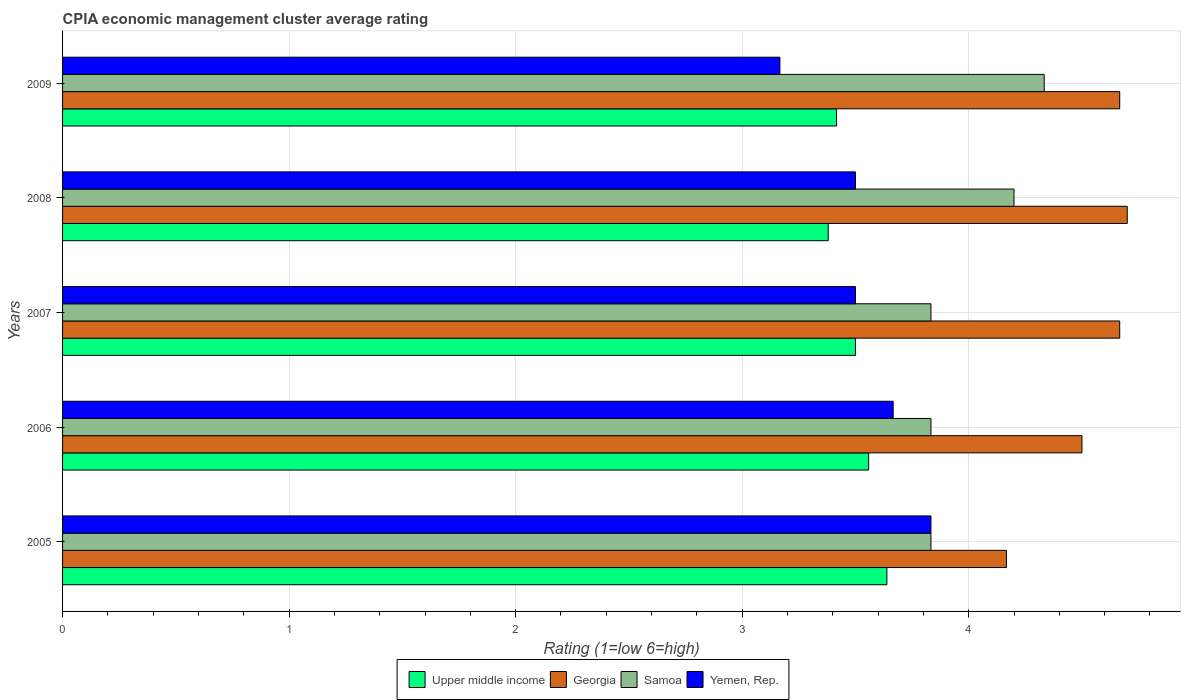How many different coloured bars are there?
Give a very brief answer. 4. How many groups of bars are there?
Your answer should be compact. 5. Are the number of bars on each tick of the Y-axis equal?
Your answer should be compact. Yes. How many bars are there on the 1st tick from the top?
Offer a terse response. 4. How many bars are there on the 1st tick from the bottom?
Ensure brevity in your answer.  4. What is the label of the 4th group of bars from the top?
Keep it short and to the point. 2006. What is the CPIA rating in Upper middle income in 2006?
Provide a short and direct response. 3.56. Across all years, what is the minimum CPIA rating in Yemen, Rep.?
Give a very brief answer. 3.17. In which year was the CPIA rating in Samoa maximum?
Ensure brevity in your answer.  2009. What is the total CPIA rating in Upper middle income in the graph?
Make the answer very short. 17.49. What is the difference between the CPIA rating in Georgia in 2006 and that in 2007?
Make the answer very short. -0.17. What is the difference between the CPIA rating in Upper middle income in 2009 and the CPIA rating in Yemen, Rep. in 2007?
Your answer should be very brief. -0.08. What is the average CPIA rating in Samoa per year?
Keep it short and to the point. 4.01. What is the ratio of the CPIA rating in Yemen, Rep. in 2007 to that in 2009?
Make the answer very short. 1.11. What is the difference between the highest and the second highest CPIA rating in Yemen, Rep.?
Provide a succinct answer. 0.17. What is the difference between the highest and the lowest CPIA rating in Georgia?
Ensure brevity in your answer.  0.53. In how many years, is the CPIA rating in Upper middle income greater than the average CPIA rating in Upper middle income taken over all years?
Your answer should be compact. 3. Is the sum of the CPIA rating in Georgia in 2007 and 2008 greater than the maximum CPIA rating in Upper middle income across all years?
Keep it short and to the point. Yes. Is it the case that in every year, the sum of the CPIA rating in Samoa and CPIA rating in Upper middle income is greater than the sum of CPIA rating in Georgia and CPIA rating in Yemen, Rep.?
Provide a short and direct response. No. What does the 1st bar from the top in 2007 represents?
Ensure brevity in your answer.  Yemen, Rep. What does the 1st bar from the bottom in 2008 represents?
Provide a short and direct response. Upper middle income. Is it the case that in every year, the sum of the CPIA rating in Yemen, Rep. and CPIA rating in Upper middle income is greater than the CPIA rating in Georgia?
Ensure brevity in your answer.  Yes. Are all the bars in the graph horizontal?
Make the answer very short. Yes. How many years are there in the graph?
Give a very brief answer. 5. Are the values on the major ticks of X-axis written in scientific E-notation?
Provide a short and direct response. No. Does the graph contain grids?
Keep it short and to the point. Yes. Where does the legend appear in the graph?
Your answer should be compact. Bottom center. How many legend labels are there?
Provide a succinct answer. 4. How are the legend labels stacked?
Your answer should be compact. Horizontal. What is the title of the graph?
Offer a very short reply. CPIA economic management cluster average rating. What is the Rating (1=low 6=high) in Upper middle income in 2005?
Provide a short and direct response. 3.64. What is the Rating (1=low 6=high) in Georgia in 2005?
Offer a very short reply. 4.17. What is the Rating (1=low 6=high) of Samoa in 2005?
Ensure brevity in your answer.  3.83. What is the Rating (1=low 6=high) in Yemen, Rep. in 2005?
Your answer should be compact. 3.83. What is the Rating (1=low 6=high) of Upper middle income in 2006?
Provide a short and direct response. 3.56. What is the Rating (1=low 6=high) in Georgia in 2006?
Offer a very short reply. 4.5. What is the Rating (1=low 6=high) in Samoa in 2006?
Give a very brief answer. 3.83. What is the Rating (1=low 6=high) in Yemen, Rep. in 2006?
Ensure brevity in your answer.  3.67. What is the Rating (1=low 6=high) in Georgia in 2007?
Offer a terse response. 4.67. What is the Rating (1=low 6=high) in Samoa in 2007?
Provide a short and direct response. 3.83. What is the Rating (1=low 6=high) of Upper middle income in 2008?
Provide a succinct answer. 3.38. What is the Rating (1=low 6=high) in Georgia in 2008?
Provide a short and direct response. 4.7. What is the Rating (1=low 6=high) of Samoa in 2008?
Your answer should be very brief. 4.2. What is the Rating (1=low 6=high) of Upper middle income in 2009?
Make the answer very short. 3.42. What is the Rating (1=low 6=high) of Georgia in 2009?
Make the answer very short. 4.67. What is the Rating (1=low 6=high) of Samoa in 2009?
Your answer should be very brief. 4.33. What is the Rating (1=low 6=high) of Yemen, Rep. in 2009?
Provide a short and direct response. 3.17. Across all years, what is the maximum Rating (1=low 6=high) in Upper middle income?
Provide a succinct answer. 3.64. Across all years, what is the maximum Rating (1=low 6=high) in Georgia?
Provide a short and direct response. 4.7. Across all years, what is the maximum Rating (1=low 6=high) in Samoa?
Make the answer very short. 4.33. Across all years, what is the maximum Rating (1=low 6=high) in Yemen, Rep.?
Your answer should be compact. 3.83. Across all years, what is the minimum Rating (1=low 6=high) of Upper middle income?
Provide a succinct answer. 3.38. Across all years, what is the minimum Rating (1=low 6=high) in Georgia?
Your response must be concise. 4.17. Across all years, what is the minimum Rating (1=low 6=high) in Samoa?
Make the answer very short. 3.83. Across all years, what is the minimum Rating (1=low 6=high) in Yemen, Rep.?
Provide a succinct answer. 3.17. What is the total Rating (1=low 6=high) of Upper middle income in the graph?
Your response must be concise. 17.49. What is the total Rating (1=low 6=high) in Georgia in the graph?
Your answer should be very brief. 22.7. What is the total Rating (1=low 6=high) of Samoa in the graph?
Keep it short and to the point. 20.03. What is the total Rating (1=low 6=high) of Yemen, Rep. in the graph?
Offer a very short reply. 17.67. What is the difference between the Rating (1=low 6=high) in Upper middle income in 2005 and that in 2006?
Keep it short and to the point. 0.08. What is the difference between the Rating (1=low 6=high) of Georgia in 2005 and that in 2006?
Provide a succinct answer. -0.33. What is the difference between the Rating (1=low 6=high) of Upper middle income in 2005 and that in 2007?
Your response must be concise. 0.14. What is the difference between the Rating (1=low 6=high) in Yemen, Rep. in 2005 and that in 2007?
Your response must be concise. 0.33. What is the difference between the Rating (1=low 6=high) of Upper middle income in 2005 and that in 2008?
Your answer should be very brief. 0.26. What is the difference between the Rating (1=low 6=high) in Georgia in 2005 and that in 2008?
Your answer should be very brief. -0.53. What is the difference between the Rating (1=low 6=high) of Samoa in 2005 and that in 2008?
Offer a terse response. -0.37. What is the difference between the Rating (1=low 6=high) of Upper middle income in 2005 and that in 2009?
Offer a very short reply. 0.22. What is the difference between the Rating (1=low 6=high) in Samoa in 2005 and that in 2009?
Provide a succinct answer. -0.5. What is the difference between the Rating (1=low 6=high) in Upper middle income in 2006 and that in 2007?
Give a very brief answer. 0.06. What is the difference between the Rating (1=low 6=high) in Yemen, Rep. in 2006 and that in 2007?
Offer a very short reply. 0.17. What is the difference between the Rating (1=low 6=high) of Upper middle income in 2006 and that in 2008?
Provide a succinct answer. 0.18. What is the difference between the Rating (1=low 6=high) in Samoa in 2006 and that in 2008?
Keep it short and to the point. -0.37. What is the difference between the Rating (1=low 6=high) in Upper middle income in 2006 and that in 2009?
Offer a very short reply. 0.14. What is the difference between the Rating (1=low 6=high) in Samoa in 2006 and that in 2009?
Offer a terse response. -0.5. What is the difference between the Rating (1=low 6=high) in Upper middle income in 2007 and that in 2008?
Offer a very short reply. 0.12. What is the difference between the Rating (1=low 6=high) in Georgia in 2007 and that in 2008?
Your answer should be very brief. -0.03. What is the difference between the Rating (1=low 6=high) in Samoa in 2007 and that in 2008?
Your answer should be compact. -0.37. What is the difference between the Rating (1=low 6=high) in Yemen, Rep. in 2007 and that in 2008?
Offer a very short reply. 0. What is the difference between the Rating (1=low 6=high) in Upper middle income in 2007 and that in 2009?
Offer a terse response. 0.08. What is the difference between the Rating (1=low 6=high) in Samoa in 2007 and that in 2009?
Provide a short and direct response. -0.5. What is the difference between the Rating (1=low 6=high) of Yemen, Rep. in 2007 and that in 2009?
Keep it short and to the point. 0.33. What is the difference between the Rating (1=low 6=high) in Upper middle income in 2008 and that in 2009?
Offer a terse response. -0.04. What is the difference between the Rating (1=low 6=high) in Samoa in 2008 and that in 2009?
Give a very brief answer. -0.13. What is the difference between the Rating (1=low 6=high) in Yemen, Rep. in 2008 and that in 2009?
Your answer should be compact. 0.33. What is the difference between the Rating (1=low 6=high) in Upper middle income in 2005 and the Rating (1=low 6=high) in Georgia in 2006?
Your answer should be compact. -0.86. What is the difference between the Rating (1=low 6=high) in Upper middle income in 2005 and the Rating (1=low 6=high) in Samoa in 2006?
Make the answer very short. -0.19. What is the difference between the Rating (1=low 6=high) of Upper middle income in 2005 and the Rating (1=low 6=high) of Yemen, Rep. in 2006?
Provide a short and direct response. -0.03. What is the difference between the Rating (1=low 6=high) of Georgia in 2005 and the Rating (1=low 6=high) of Samoa in 2006?
Give a very brief answer. 0.33. What is the difference between the Rating (1=low 6=high) in Upper middle income in 2005 and the Rating (1=low 6=high) in Georgia in 2007?
Your answer should be compact. -1.03. What is the difference between the Rating (1=low 6=high) in Upper middle income in 2005 and the Rating (1=low 6=high) in Samoa in 2007?
Provide a succinct answer. -0.19. What is the difference between the Rating (1=low 6=high) of Upper middle income in 2005 and the Rating (1=low 6=high) of Yemen, Rep. in 2007?
Give a very brief answer. 0.14. What is the difference between the Rating (1=low 6=high) in Georgia in 2005 and the Rating (1=low 6=high) in Samoa in 2007?
Give a very brief answer. 0.33. What is the difference between the Rating (1=low 6=high) of Samoa in 2005 and the Rating (1=low 6=high) of Yemen, Rep. in 2007?
Keep it short and to the point. 0.33. What is the difference between the Rating (1=low 6=high) in Upper middle income in 2005 and the Rating (1=low 6=high) in Georgia in 2008?
Your answer should be very brief. -1.06. What is the difference between the Rating (1=low 6=high) of Upper middle income in 2005 and the Rating (1=low 6=high) of Samoa in 2008?
Ensure brevity in your answer.  -0.56. What is the difference between the Rating (1=low 6=high) in Upper middle income in 2005 and the Rating (1=low 6=high) in Yemen, Rep. in 2008?
Provide a succinct answer. 0.14. What is the difference between the Rating (1=low 6=high) of Georgia in 2005 and the Rating (1=low 6=high) of Samoa in 2008?
Your answer should be compact. -0.03. What is the difference between the Rating (1=low 6=high) of Georgia in 2005 and the Rating (1=low 6=high) of Yemen, Rep. in 2008?
Keep it short and to the point. 0.67. What is the difference between the Rating (1=low 6=high) of Samoa in 2005 and the Rating (1=low 6=high) of Yemen, Rep. in 2008?
Keep it short and to the point. 0.33. What is the difference between the Rating (1=low 6=high) in Upper middle income in 2005 and the Rating (1=low 6=high) in Georgia in 2009?
Your answer should be compact. -1.03. What is the difference between the Rating (1=low 6=high) of Upper middle income in 2005 and the Rating (1=low 6=high) of Samoa in 2009?
Offer a very short reply. -0.69. What is the difference between the Rating (1=low 6=high) in Upper middle income in 2005 and the Rating (1=low 6=high) in Yemen, Rep. in 2009?
Offer a terse response. 0.47. What is the difference between the Rating (1=low 6=high) in Georgia in 2005 and the Rating (1=low 6=high) in Samoa in 2009?
Your answer should be very brief. -0.17. What is the difference between the Rating (1=low 6=high) in Georgia in 2005 and the Rating (1=low 6=high) in Yemen, Rep. in 2009?
Keep it short and to the point. 1. What is the difference between the Rating (1=low 6=high) in Samoa in 2005 and the Rating (1=low 6=high) in Yemen, Rep. in 2009?
Your answer should be very brief. 0.67. What is the difference between the Rating (1=low 6=high) of Upper middle income in 2006 and the Rating (1=low 6=high) of Georgia in 2007?
Your response must be concise. -1.11. What is the difference between the Rating (1=low 6=high) of Upper middle income in 2006 and the Rating (1=low 6=high) of Samoa in 2007?
Your answer should be very brief. -0.28. What is the difference between the Rating (1=low 6=high) in Upper middle income in 2006 and the Rating (1=low 6=high) in Yemen, Rep. in 2007?
Your response must be concise. 0.06. What is the difference between the Rating (1=low 6=high) of Georgia in 2006 and the Rating (1=low 6=high) of Yemen, Rep. in 2007?
Provide a succinct answer. 1. What is the difference between the Rating (1=low 6=high) in Samoa in 2006 and the Rating (1=low 6=high) in Yemen, Rep. in 2007?
Your answer should be very brief. 0.33. What is the difference between the Rating (1=low 6=high) of Upper middle income in 2006 and the Rating (1=low 6=high) of Georgia in 2008?
Make the answer very short. -1.14. What is the difference between the Rating (1=low 6=high) of Upper middle income in 2006 and the Rating (1=low 6=high) of Samoa in 2008?
Offer a terse response. -0.64. What is the difference between the Rating (1=low 6=high) in Upper middle income in 2006 and the Rating (1=low 6=high) in Yemen, Rep. in 2008?
Your response must be concise. 0.06. What is the difference between the Rating (1=low 6=high) of Georgia in 2006 and the Rating (1=low 6=high) of Yemen, Rep. in 2008?
Ensure brevity in your answer.  1. What is the difference between the Rating (1=low 6=high) in Samoa in 2006 and the Rating (1=low 6=high) in Yemen, Rep. in 2008?
Make the answer very short. 0.33. What is the difference between the Rating (1=low 6=high) of Upper middle income in 2006 and the Rating (1=low 6=high) of Georgia in 2009?
Offer a terse response. -1.11. What is the difference between the Rating (1=low 6=high) of Upper middle income in 2006 and the Rating (1=low 6=high) of Samoa in 2009?
Offer a very short reply. -0.78. What is the difference between the Rating (1=low 6=high) of Upper middle income in 2006 and the Rating (1=low 6=high) of Yemen, Rep. in 2009?
Offer a terse response. 0.39. What is the difference between the Rating (1=low 6=high) of Samoa in 2006 and the Rating (1=low 6=high) of Yemen, Rep. in 2009?
Your response must be concise. 0.67. What is the difference between the Rating (1=low 6=high) of Upper middle income in 2007 and the Rating (1=low 6=high) of Georgia in 2008?
Your response must be concise. -1.2. What is the difference between the Rating (1=low 6=high) in Georgia in 2007 and the Rating (1=low 6=high) in Samoa in 2008?
Offer a terse response. 0.47. What is the difference between the Rating (1=low 6=high) in Upper middle income in 2007 and the Rating (1=low 6=high) in Georgia in 2009?
Provide a short and direct response. -1.17. What is the difference between the Rating (1=low 6=high) in Samoa in 2007 and the Rating (1=low 6=high) in Yemen, Rep. in 2009?
Provide a short and direct response. 0.67. What is the difference between the Rating (1=low 6=high) of Upper middle income in 2008 and the Rating (1=low 6=high) of Georgia in 2009?
Your response must be concise. -1.29. What is the difference between the Rating (1=low 6=high) of Upper middle income in 2008 and the Rating (1=low 6=high) of Samoa in 2009?
Make the answer very short. -0.95. What is the difference between the Rating (1=low 6=high) in Upper middle income in 2008 and the Rating (1=low 6=high) in Yemen, Rep. in 2009?
Keep it short and to the point. 0.21. What is the difference between the Rating (1=low 6=high) of Georgia in 2008 and the Rating (1=low 6=high) of Samoa in 2009?
Keep it short and to the point. 0.37. What is the difference between the Rating (1=low 6=high) of Georgia in 2008 and the Rating (1=low 6=high) of Yemen, Rep. in 2009?
Your answer should be compact. 1.53. What is the difference between the Rating (1=low 6=high) in Samoa in 2008 and the Rating (1=low 6=high) in Yemen, Rep. in 2009?
Ensure brevity in your answer.  1.03. What is the average Rating (1=low 6=high) in Upper middle income per year?
Provide a short and direct response. 3.5. What is the average Rating (1=low 6=high) of Georgia per year?
Provide a short and direct response. 4.54. What is the average Rating (1=low 6=high) of Samoa per year?
Ensure brevity in your answer.  4.01. What is the average Rating (1=low 6=high) in Yemen, Rep. per year?
Your answer should be very brief. 3.53. In the year 2005, what is the difference between the Rating (1=low 6=high) of Upper middle income and Rating (1=low 6=high) of Georgia?
Offer a terse response. -0.53. In the year 2005, what is the difference between the Rating (1=low 6=high) of Upper middle income and Rating (1=low 6=high) of Samoa?
Provide a succinct answer. -0.19. In the year 2005, what is the difference between the Rating (1=low 6=high) in Upper middle income and Rating (1=low 6=high) in Yemen, Rep.?
Keep it short and to the point. -0.19. In the year 2005, what is the difference between the Rating (1=low 6=high) in Georgia and Rating (1=low 6=high) in Samoa?
Your answer should be very brief. 0.33. In the year 2005, what is the difference between the Rating (1=low 6=high) in Georgia and Rating (1=low 6=high) in Yemen, Rep.?
Offer a very short reply. 0.33. In the year 2006, what is the difference between the Rating (1=low 6=high) of Upper middle income and Rating (1=low 6=high) of Georgia?
Offer a terse response. -0.94. In the year 2006, what is the difference between the Rating (1=low 6=high) in Upper middle income and Rating (1=low 6=high) in Samoa?
Make the answer very short. -0.28. In the year 2006, what is the difference between the Rating (1=low 6=high) of Upper middle income and Rating (1=low 6=high) of Yemen, Rep.?
Provide a short and direct response. -0.11. In the year 2006, what is the difference between the Rating (1=low 6=high) of Samoa and Rating (1=low 6=high) of Yemen, Rep.?
Your answer should be compact. 0.17. In the year 2007, what is the difference between the Rating (1=low 6=high) in Upper middle income and Rating (1=low 6=high) in Georgia?
Give a very brief answer. -1.17. In the year 2007, what is the difference between the Rating (1=low 6=high) in Georgia and Rating (1=low 6=high) in Samoa?
Provide a short and direct response. 0.83. In the year 2008, what is the difference between the Rating (1=low 6=high) in Upper middle income and Rating (1=low 6=high) in Georgia?
Make the answer very short. -1.32. In the year 2008, what is the difference between the Rating (1=low 6=high) in Upper middle income and Rating (1=low 6=high) in Samoa?
Provide a succinct answer. -0.82. In the year 2008, what is the difference between the Rating (1=low 6=high) in Upper middle income and Rating (1=low 6=high) in Yemen, Rep.?
Provide a short and direct response. -0.12. In the year 2008, what is the difference between the Rating (1=low 6=high) in Georgia and Rating (1=low 6=high) in Samoa?
Keep it short and to the point. 0.5. In the year 2008, what is the difference between the Rating (1=low 6=high) in Samoa and Rating (1=low 6=high) in Yemen, Rep.?
Give a very brief answer. 0.7. In the year 2009, what is the difference between the Rating (1=low 6=high) of Upper middle income and Rating (1=low 6=high) of Georgia?
Provide a succinct answer. -1.25. In the year 2009, what is the difference between the Rating (1=low 6=high) of Upper middle income and Rating (1=low 6=high) of Samoa?
Provide a succinct answer. -0.92. In the year 2009, what is the difference between the Rating (1=low 6=high) of Samoa and Rating (1=low 6=high) of Yemen, Rep.?
Your answer should be very brief. 1.17. What is the ratio of the Rating (1=low 6=high) in Upper middle income in 2005 to that in 2006?
Your response must be concise. 1.02. What is the ratio of the Rating (1=low 6=high) of Georgia in 2005 to that in 2006?
Your response must be concise. 0.93. What is the ratio of the Rating (1=low 6=high) of Samoa in 2005 to that in 2006?
Give a very brief answer. 1. What is the ratio of the Rating (1=low 6=high) of Yemen, Rep. in 2005 to that in 2006?
Offer a very short reply. 1.05. What is the ratio of the Rating (1=low 6=high) of Upper middle income in 2005 to that in 2007?
Give a very brief answer. 1.04. What is the ratio of the Rating (1=low 6=high) in Georgia in 2005 to that in 2007?
Keep it short and to the point. 0.89. What is the ratio of the Rating (1=low 6=high) in Samoa in 2005 to that in 2007?
Provide a succinct answer. 1. What is the ratio of the Rating (1=low 6=high) of Yemen, Rep. in 2005 to that in 2007?
Give a very brief answer. 1.1. What is the ratio of the Rating (1=low 6=high) of Upper middle income in 2005 to that in 2008?
Provide a short and direct response. 1.08. What is the ratio of the Rating (1=low 6=high) in Georgia in 2005 to that in 2008?
Provide a short and direct response. 0.89. What is the ratio of the Rating (1=low 6=high) in Samoa in 2005 to that in 2008?
Your answer should be very brief. 0.91. What is the ratio of the Rating (1=low 6=high) of Yemen, Rep. in 2005 to that in 2008?
Keep it short and to the point. 1.1. What is the ratio of the Rating (1=low 6=high) of Upper middle income in 2005 to that in 2009?
Offer a very short reply. 1.06. What is the ratio of the Rating (1=low 6=high) in Georgia in 2005 to that in 2009?
Give a very brief answer. 0.89. What is the ratio of the Rating (1=low 6=high) of Samoa in 2005 to that in 2009?
Make the answer very short. 0.88. What is the ratio of the Rating (1=low 6=high) in Yemen, Rep. in 2005 to that in 2009?
Ensure brevity in your answer.  1.21. What is the ratio of the Rating (1=low 6=high) of Upper middle income in 2006 to that in 2007?
Provide a short and direct response. 1.02. What is the ratio of the Rating (1=low 6=high) in Georgia in 2006 to that in 2007?
Make the answer very short. 0.96. What is the ratio of the Rating (1=low 6=high) of Yemen, Rep. in 2006 to that in 2007?
Keep it short and to the point. 1.05. What is the ratio of the Rating (1=low 6=high) in Upper middle income in 2006 to that in 2008?
Your answer should be compact. 1.05. What is the ratio of the Rating (1=low 6=high) in Georgia in 2006 to that in 2008?
Offer a very short reply. 0.96. What is the ratio of the Rating (1=low 6=high) in Samoa in 2006 to that in 2008?
Make the answer very short. 0.91. What is the ratio of the Rating (1=low 6=high) of Yemen, Rep. in 2006 to that in 2008?
Your answer should be compact. 1.05. What is the ratio of the Rating (1=low 6=high) of Upper middle income in 2006 to that in 2009?
Give a very brief answer. 1.04. What is the ratio of the Rating (1=low 6=high) in Samoa in 2006 to that in 2009?
Keep it short and to the point. 0.88. What is the ratio of the Rating (1=low 6=high) of Yemen, Rep. in 2006 to that in 2009?
Provide a short and direct response. 1.16. What is the ratio of the Rating (1=low 6=high) in Upper middle income in 2007 to that in 2008?
Your response must be concise. 1.04. What is the ratio of the Rating (1=low 6=high) in Georgia in 2007 to that in 2008?
Your answer should be compact. 0.99. What is the ratio of the Rating (1=low 6=high) of Samoa in 2007 to that in 2008?
Your answer should be very brief. 0.91. What is the ratio of the Rating (1=low 6=high) of Yemen, Rep. in 2007 to that in 2008?
Your response must be concise. 1. What is the ratio of the Rating (1=low 6=high) of Upper middle income in 2007 to that in 2009?
Your answer should be very brief. 1.02. What is the ratio of the Rating (1=low 6=high) of Samoa in 2007 to that in 2009?
Your response must be concise. 0.88. What is the ratio of the Rating (1=low 6=high) in Yemen, Rep. in 2007 to that in 2009?
Make the answer very short. 1.11. What is the ratio of the Rating (1=low 6=high) in Upper middle income in 2008 to that in 2009?
Your answer should be very brief. 0.99. What is the ratio of the Rating (1=low 6=high) of Georgia in 2008 to that in 2009?
Offer a terse response. 1.01. What is the ratio of the Rating (1=low 6=high) of Samoa in 2008 to that in 2009?
Keep it short and to the point. 0.97. What is the ratio of the Rating (1=low 6=high) in Yemen, Rep. in 2008 to that in 2009?
Offer a terse response. 1.11. What is the difference between the highest and the second highest Rating (1=low 6=high) of Upper middle income?
Give a very brief answer. 0.08. What is the difference between the highest and the second highest Rating (1=low 6=high) of Georgia?
Your answer should be compact. 0.03. What is the difference between the highest and the second highest Rating (1=low 6=high) in Samoa?
Your answer should be compact. 0.13. What is the difference between the highest and the second highest Rating (1=low 6=high) in Yemen, Rep.?
Provide a succinct answer. 0.17. What is the difference between the highest and the lowest Rating (1=low 6=high) in Upper middle income?
Offer a very short reply. 0.26. What is the difference between the highest and the lowest Rating (1=low 6=high) in Georgia?
Offer a very short reply. 0.53. What is the difference between the highest and the lowest Rating (1=low 6=high) in Samoa?
Keep it short and to the point. 0.5. What is the difference between the highest and the lowest Rating (1=low 6=high) of Yemen, Rep.?
Keep it short and to the point. 0.67. 